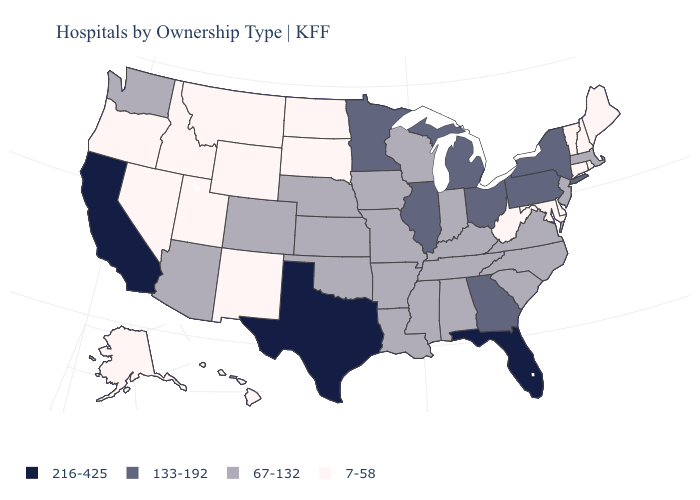Does Hawaii have the lowest value in the USA?
Answer briefly. Yes. Name the states that have a value in the range 216-425?
Keep it brief. California, Florida, Texas. What is the value of Maine?
Give a very brief answer. 7-58. Which states have the highest value in the USA?
Concise answer only. California, Florida, Texas. Does New Mexico have the lowest value in the USA?
Give a very brief answer. Yes. Name the states that have a value in the range 133-192?
Short answer required. Georgia, Illinois, Michigan, Minnesota, New York, Ohio, Pennsylvania. What is the value of Alabama?
Answer briefly. 67-132. Does Vermont have the lowest value in the USA?
Write a very short answer. Yes. What is the value of Michigan?
Short answer required. 133-192. Which states hav the highest value in the West?
Give a very brief answer. California. Does Iowa have the same value as Washington?
Be succinct. Yes. What is the value of South Dakota?
Concise answer only. 7-58. Does the map have missing data?
Keep it brief. No. What is the highest value in states that border Illinois?
Give a very brief answer. 67-132. 